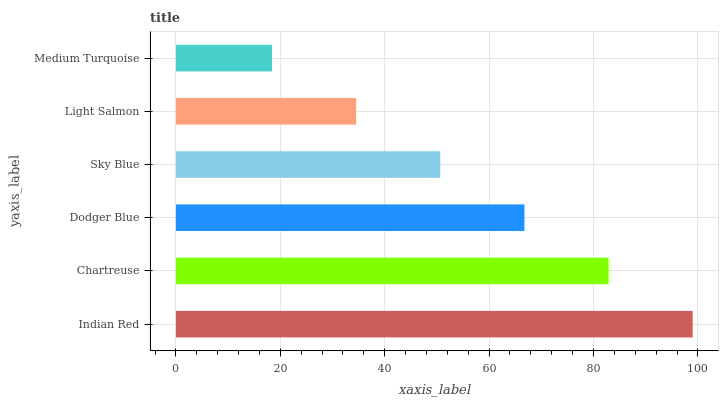Is Medium Turquoise the minimum?
Answer yes or no. Yes. Is Indian Red the maximum?
Answer yes or no. Yes. Is Chartreuse the minimum?
Answer yes or no. No. Is Chartreuse the maximum?
Answer yes or no. No. Is Indian Red greater than Chartreuse?
Answer yes or no. Yes. Is Chartreuse less than Indian Red?
Answer yes or no. Yes. Is Chartreuse greater than Indian Red?
Answer yes or no. No. Is Indian Red less than Chartreuse?
Answer yes or no. No. Is Dodger Blue the high median?
Answer yes or no. Yes. Is Sky Blue the low median?
Answer yes or no. Yes. Is Sky Blue the high median?
Answer yes or no. No. Is Medium Turquoise the low median?
Answer yes or no. No. 